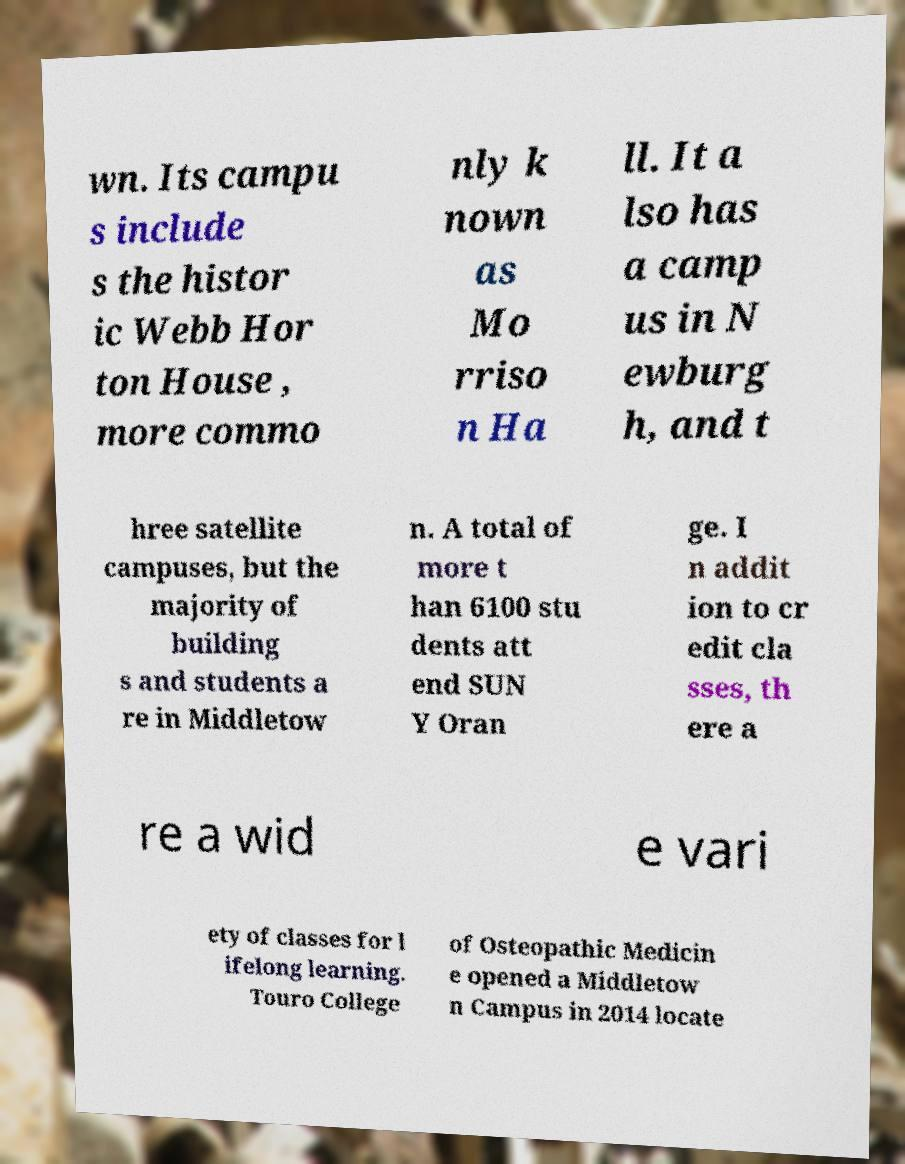Please identify and transcribe the text found in this image. wn. Its campu s include s the histor ic Webb Hor ton House , more commo nly k nown as Mo rriso n Ha ll. It a lso has a camp us in N ewburg h, and t hree satellite campuses, but the majority of building s and students a re in Middletow n. A total of more t han 6100 stu dents att end SUN Y Oran ge. I n addit ion to cr edit cla sses, th ere a re a wid e vari ety of classes for l ifelong learning. Touro College of Osteopathic Medicin e opened a Middletow n Campus in 2014 locate 